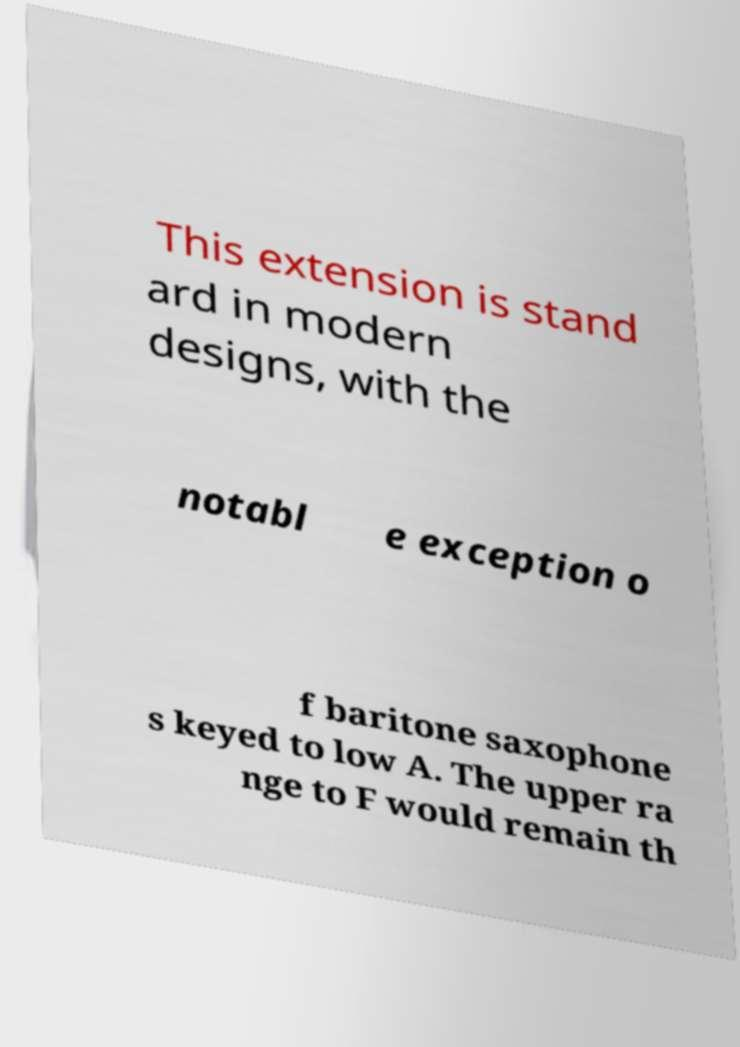For documentation purposes, I need the text within this image transcribed. Could you provide that? This extension is stand ard in modern designs, with the notabl e exception o f baritone saxophone s keyed to low A. The upper ra nge to F would remain th 